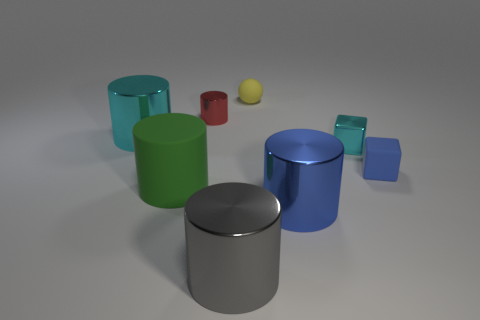Subtract all shiny cylinders. How many cylinders are left? 1 Subtract 3 cylinders. How many cylinders are left? 2 Subtract all red cylinders. How many cylinders are left? 4 Add 1 small yellow spheres. How many objects exist? 9 Subtract all brown cylinders. Subtract all brown blocks. How many cylinders are left? 5 Subtract all cylinders. How many objects are left? 3 Subtract 0 green blocks. How many objects are left? 8 Subtract all big cyan metallic cylinders. Subtract all tiny red objects. How many objects are left? 6 Add 8 small blue matte objects. How many small blue matte objects are left? 9 Add 3 metallic cylinders. How many metallic cylinders exist? 7 